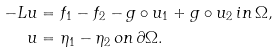<formula> <loc_0><loc_0><loc_500><loc_500>- L u & = f _ { 1 } - f _ { 2 } - g \circ u _ { 1 } + g \circ u _ { 2 } \, i n \, \Omega , \\ u & = \eta _ { 1 } - \eta _ { 2 } \, o n \, \partial \Omega .</formula> 